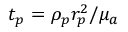Convert formula to latex. <formula><loc_0><loc_0><loc_500><loc_500>t _ { p } = \rho _ { p } r _ { p } ^ { 2 } / \mu _ { a }</formula> 